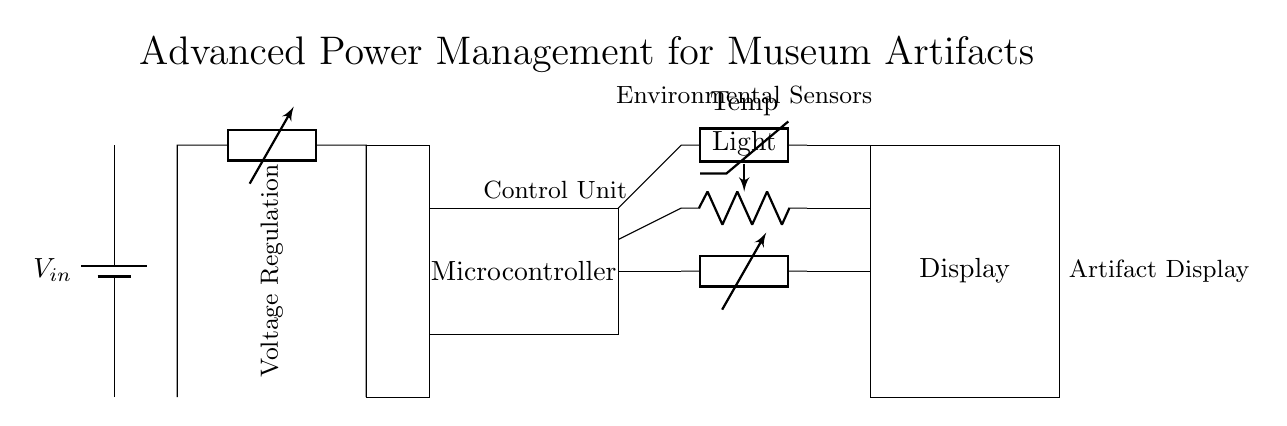What does the circuit manage? The circuit manages power for displaying delicate museum artifacts, designed to maintain optimal conditions for preservation.
Answer: Power management What component regulates voltage? The DC-DC converter is responsible for regulating voltage, ensuring that the output voltage is controlled for the circuit's needs.
Answer: DC-DC converter How many environmental sensors are present? There are three environmental sensors: a thermistor for temperature, a photoresistor for light, and a generic sensor for humidity.
Answer: Three What is the role of the microcontroller? The microcontroller acts as a control unit, processing input from sensors and managing the power output for display functions.
Answer: Control unit Which component interfaces with the output display? The component that interfaces with the output display is the microcontroller, which processes sensor data to control the display.
Answer: Microcontroller What types of environmental factors are being monitored? The circuit monitors temperature, light, and humidity, which are critical for the preservation of artifacts.
Answer: Temperature, light, humidity What is the power supply voltage? The power supply voltage is represented as Vin, but the specific value is not provided within the circuit diagram itself.
Answer: Vin 